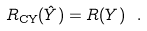<formula> <loc_0><loc_0><loc_500><loc_500>R _ { \text {CY} } ( \hat { Y } ) = R ( Y ) \ .</formula> 